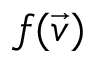Convert formula to latex. <formula><loc_0><loc_0><loc_500><loc_500>f ( \vec { v } )</formula> 